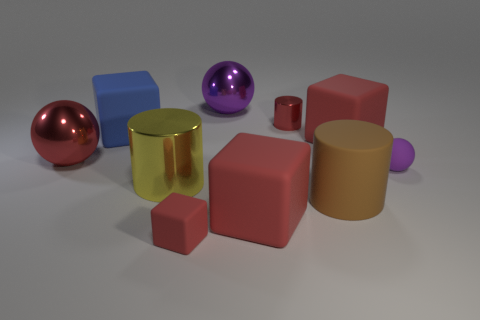There is a small rubber thing left of the brown cylinder; how many spheres are in front of it?
Ensure brevity in your answer.  0. There is a small block; is it the same color as the shiny object that is in front of the tiny purple sphere?
Your response must be concise. No. The rubber block that is the same size as the rubber sphere is what color?
Your answer should be compact. Red. Are there any big purple matte objects of the same shape as the tiny purple thing?
Give a very brief answer. No. Are there fewer yellow cylinders than big cubes?
Keep it short and to the point. Yes. There is a large ball on the left side of the large yellow metal object; what color is it?
Offer a very short reply. Red. What shape is the large metal object behind the red metal thing that is in front of the big blue cube?
Your answer should be very brief. Sphere. Are the small red cylinder and the large red cube that is behind the tiny purple thing made of the same material?
Your answer should be compact. No. There is a big thing that is the same color as the rubber sphere; what is its shape?
Provide a succinct answer. Sphere. What number of red rubber things are the same size as the red shiny cylinder?
Make the answer very short. 1. 